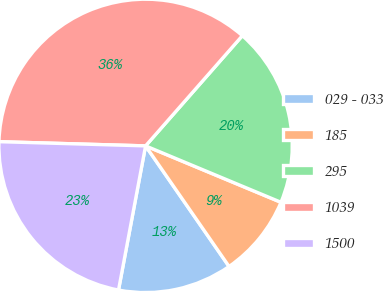Convert chart. <chart><loc_0><loc_0><loc_500><loc_500><pie_chart><fcel>029 - 033<fcel>185<fcel>295<fcel>1039<fcel>1500<nl><fcel>12.59%<fcel>9.08%<fcel>19.81%<fcel>36.01%<fcel>22.5%<nl></chart> 